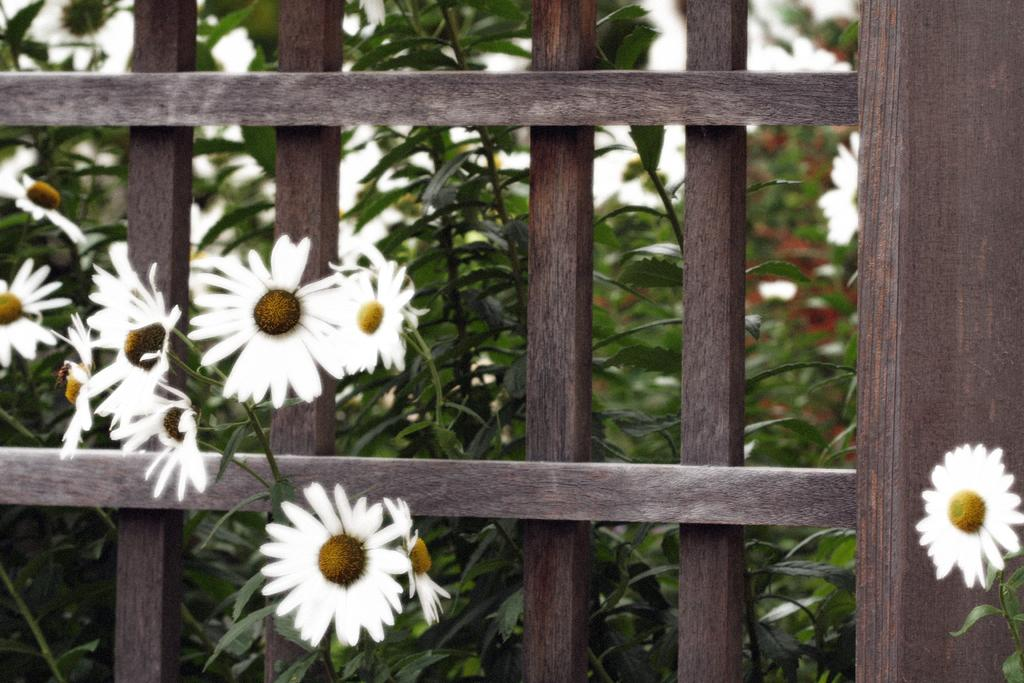What type of plants are visible in the image? There are plants with flowers in the image. What is the other main subject in the image? There is a fence in the image. Can you tell me how many kernels of popcorn are visible in the image? There is no popcorn present in the image. What type of example can be seen in the image? There is no example present in the image; it features plants with flowers and a fence. 